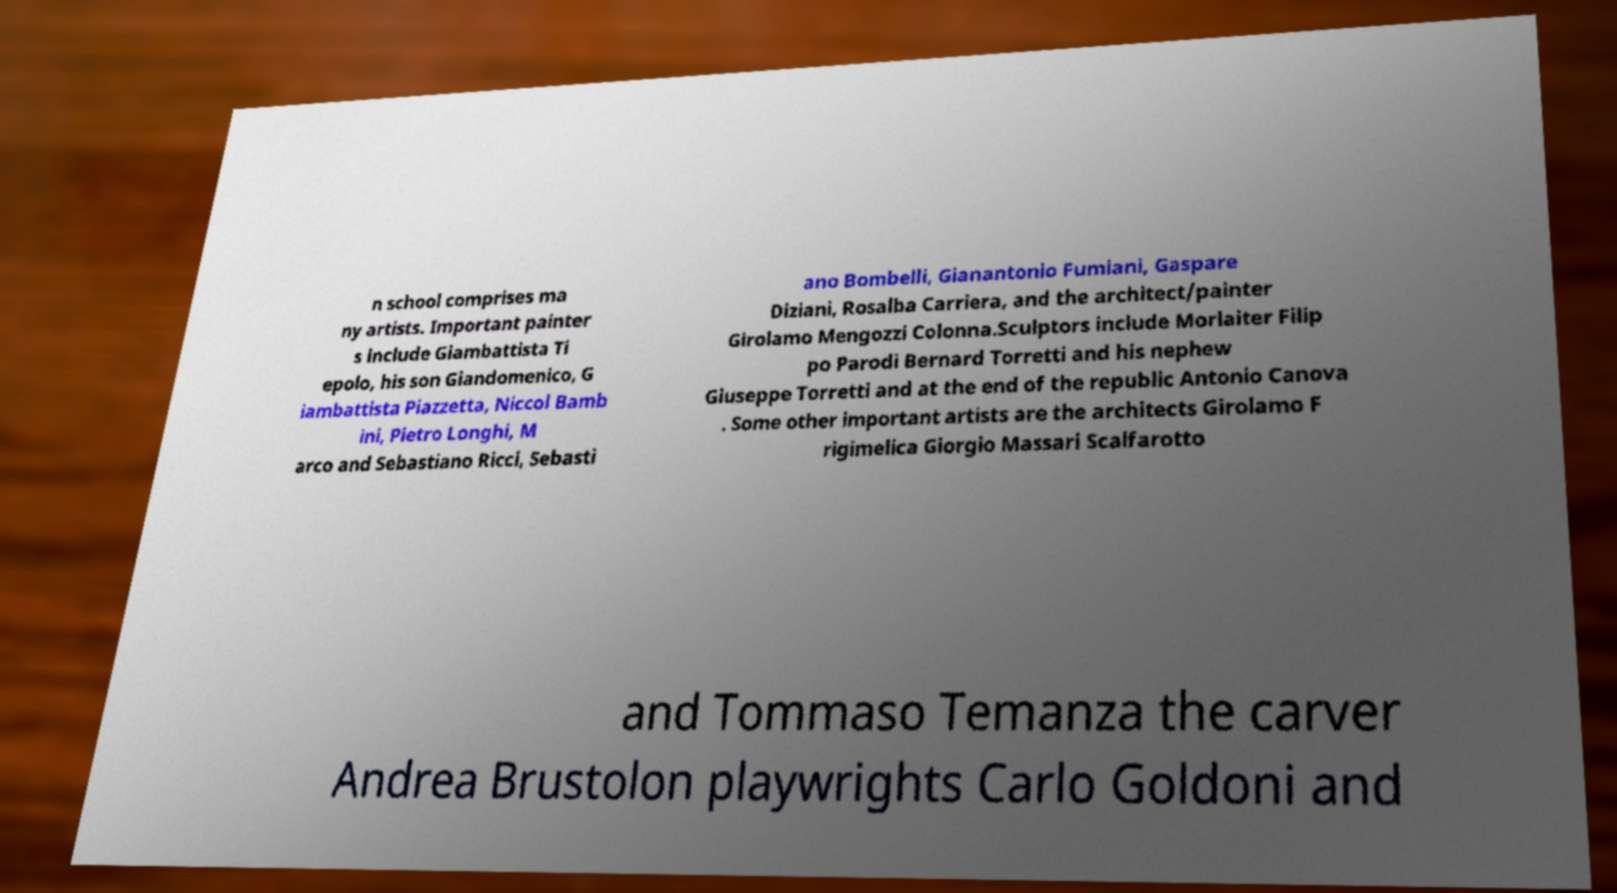Can you read and provide the text displayed in the image?This photo seems to have some interesting text. Can you extract and type it out for me? n school comprises ma ny artists. Important painter s include Giambattista Ti epolo, his son Giandomenico, G iambattista Piazzetta, Niccol Bamb ini, Pietro Longhi, M arco and Sebastiano Ricci, Sebasti ano Bombelli, Gianantonio Fumiani, Gaspare Diziani, Rosalba Carriera, and the architect/painter Girolamo Mengozzi Colonna.Sculptors include Morlaiter Filip po Parodi Bernard Torretti and his nephew Giuseppe Torretti and at the end of the republic Antonio Canova . Some other important artists are the architects Girolamo F rigimelica Giorgio Massari Scalfarotto and Tommaso Temanza the carver Andrea Brustolon playwrights Carlo Goldoni and 